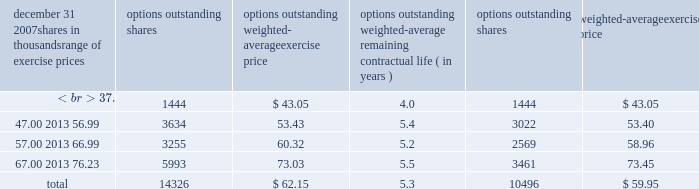Information about stock options at december 31 , 2007 follows: .
( a ) the weighted-average remaining contractual life was approximately 4.2 years .
At december 31 , 2007 , there were approximately 13788000 options in total that were vested and are expected to vest .
The weighted-average exercise price of such options was $ 62.07 per share , the weighted-average remaining contractual life was approximately 5.2 years , and the aggregate intrinsic value at december 31 , 2007 was approximately $ 92 million .
Stock options granted in 2005 include options for 30000 shares that were granted to non-employee directors that year .
No such options were granted in 2006 or 2007 .
Awards granted to non-employee directors in 2007 include 20944 deferred stock units awarded under the outside directors deferred stock unit plan .
A deferred stock unit is a phantom share of our common stock , which requires liability accounting treatment under sfas 123r until such awards are paid to the participants as cash .
As there are no vestings or service requirements on these awards , total compensation expense is recognized in full on all awarded units on the date of grant .
The weighted-average grant-date fair value of options granted in 2007 , 2006 and 2005 was $ 11.37 , $ 10.75 and $ 9.83 per option , respectively .
To determine stock-based compensation expense under sfas 123r , the grant-date fair value is applied to the options granted with a reduction made for estimated forfeitures .
At december 31 , 2006 and 2005 options for 10743000 and 13582000 shares of common stock , respectively , were exercisable at a weighted-average price of $ 58.38 and $ 56.58 , respectively .
The total intrinsic value of options exercised during 2007 , 2006 and 2005 was $ 52 million , $ 111 million and $ 31 million , respectively .
At december 31 , 2007 the aggregate intrinsic value of all options outstanding and exercisable was $ 94 million and $ 87 million , respectively .
Cash received from option exercises under all incentive plans for 2007 , 2006 and 2005 was approximately $ 111 million , $ 233 million and $ 98 million , respectively .
The actual tax benefit realized for tax deduction purposes from option exercises under all incentive plans for 2007 , 2006 and 2005 was approximately $ 39 million , $ 82 million and $ 34 million , respectively .
There were no options granted in excess of market value in 2007 , 2006 or 2005 .
Shares of common stock available during the next year for the granting of options and other awards under the incentive plans were 40116726 at december 31 , 2007 .
Total shares of pnc common stock authorized for future issuance under equity compensation plans totaled 41787400 shares at december 31 , 2007 , which includes shares available for issuance under the incentive plans , the employee stock purchase plan as described below , and a director plan .
During 2007 , we issued approximately 2.1 million shares from treasury stock in connection with stock option exercise activity .
As with past exercise activity , we intend to utilize treasury stock for future stock option exercises .
As discussed in note 1 accounting policies , we adopted the fair value recognition provisions of sfas 123 prospectively to all employee awards including stock options granted , modified or settled after january 1 , 2003 .
As permitted under sfas 123 , we recognized compensation expense for stock options on a straight-line basis over the pro rata vesting period .
Total compensation expense recognized related to pnc stock options in 2007 was $ 29 million compared with $ 31 million in 2006 and $ 29 million in 2005 .
Pro forma effects a table is included in note 1 accounting policies that sets forth pro forma net income and basic and diluted earnings per share as if compensation expense had been recognized under sfas 123 and 123r , as amended , for stock options for 2005 .
For purposes of computing stock option expense and 2005 pro forma results , we estimated the fair value of stock options using the black-scholes option pricing model .
The model requires the use of numerous assumptions , many of which are very subjective .
Therefore , the 2005 pro forma results are estimates of results of operations as if compensation expense had been recognized for all stock-based compensation awards and are not indicative of the impact on future periods. .
For the years ended december 31 , 2006 and 2005 what was the average weighted-average exercise price for options outstanding? 
Computations: ((58.38 + 56.58) / 2)
Answer: 57.48. 